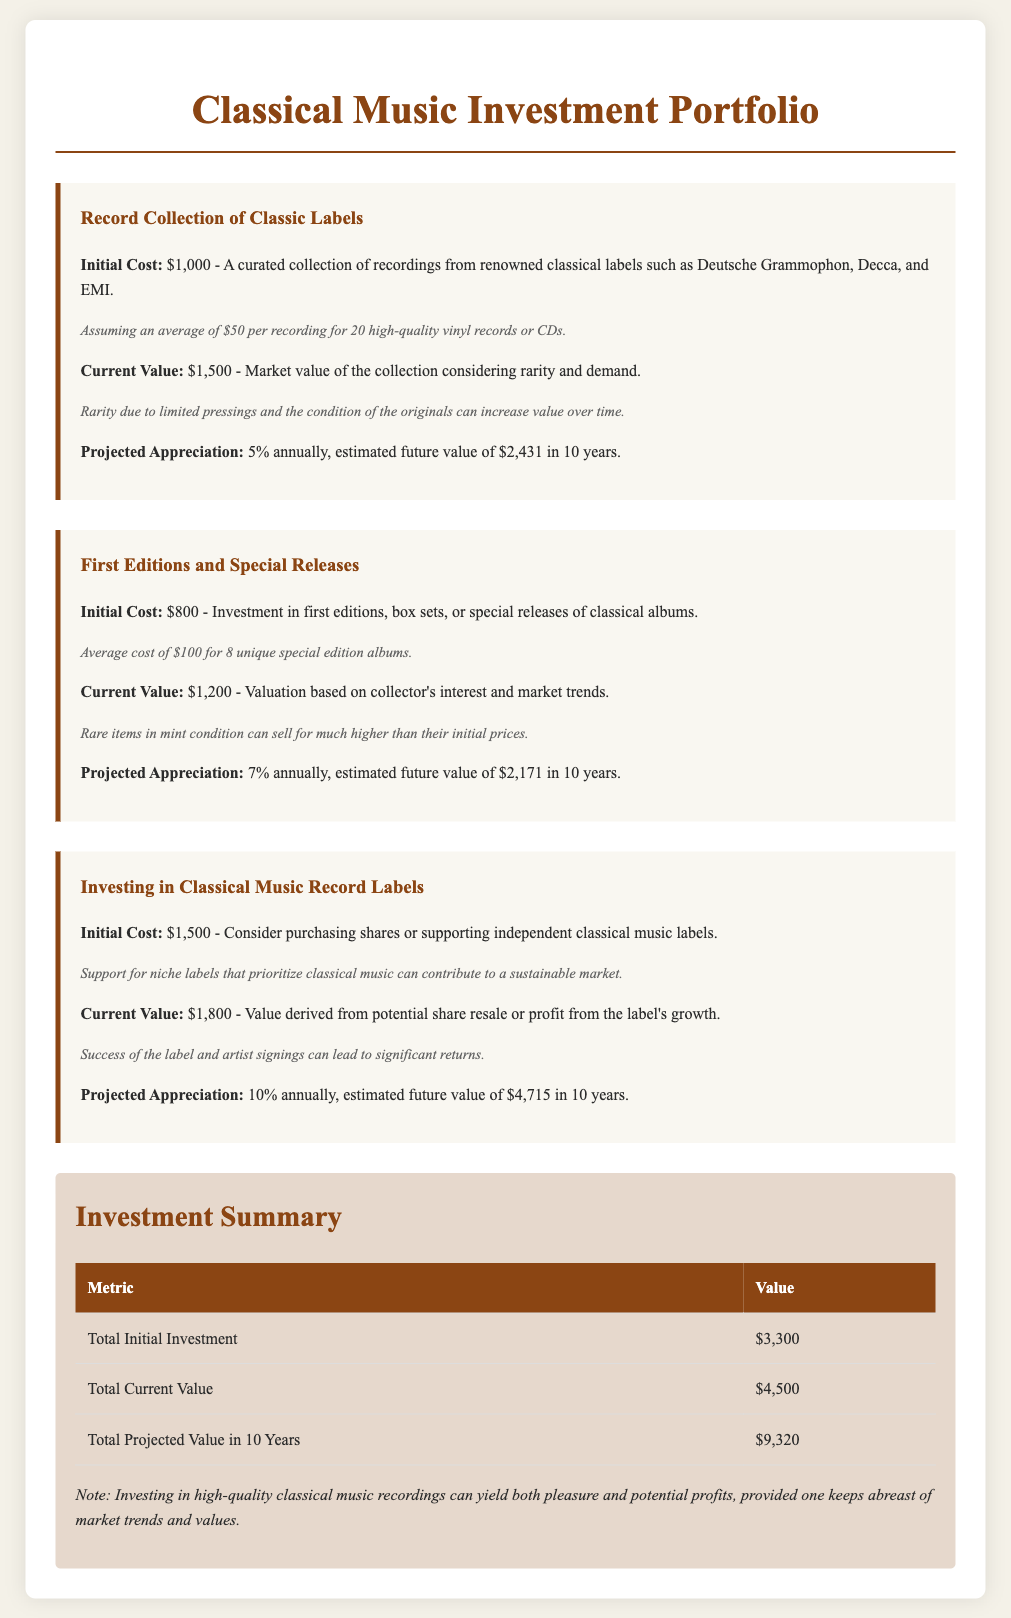what is the initial cost of the Record Collection of Classic Labels? The initial cost is stated as $1,000 for the curated collection of recordings.
Answer: $1,000 what is the projected appreciation rate for First Editions and Special Releases? The projected appreciation rate is mentioned as 7% annually for this investment.
Answer: 7% what is the current value of the investment in Classical Music Record Labels? The current value for investing in classical music record labels is specified as $1,800.
Answer: $1,800 what will be the estimated future value of the Record Collection of Classic Labels in 10 years? The estimated future value is projected to be $2,431 in 10 years.
Answer: $2,431 what is the total initial investment across all categories? The total initial investment is calculated as $3,300 by adding the initial costs of all investments.
Answer: $3,300 what is the current total value of all investments? The current total value amounts to $4,500 as stated in the summary section.
Answer: $4,500 which investment has the highest projected appreciation rate? The investment with the highest projected appreciation rate is identified as Investing in Classical Music Record Labels at 10% annually.
Answer: 10% how much is expected to be the total projected value in 10 years? The total projected value in 10 years is stated as $9,320.
Answer: $9,320 what are the classical music labels mentioned in the investment? The classic labels mentioned include Deutsche Grammophon, Decca, and EMI in the context of the record collection.
Answer: Deutsche Grammophon, Decca, EMI 